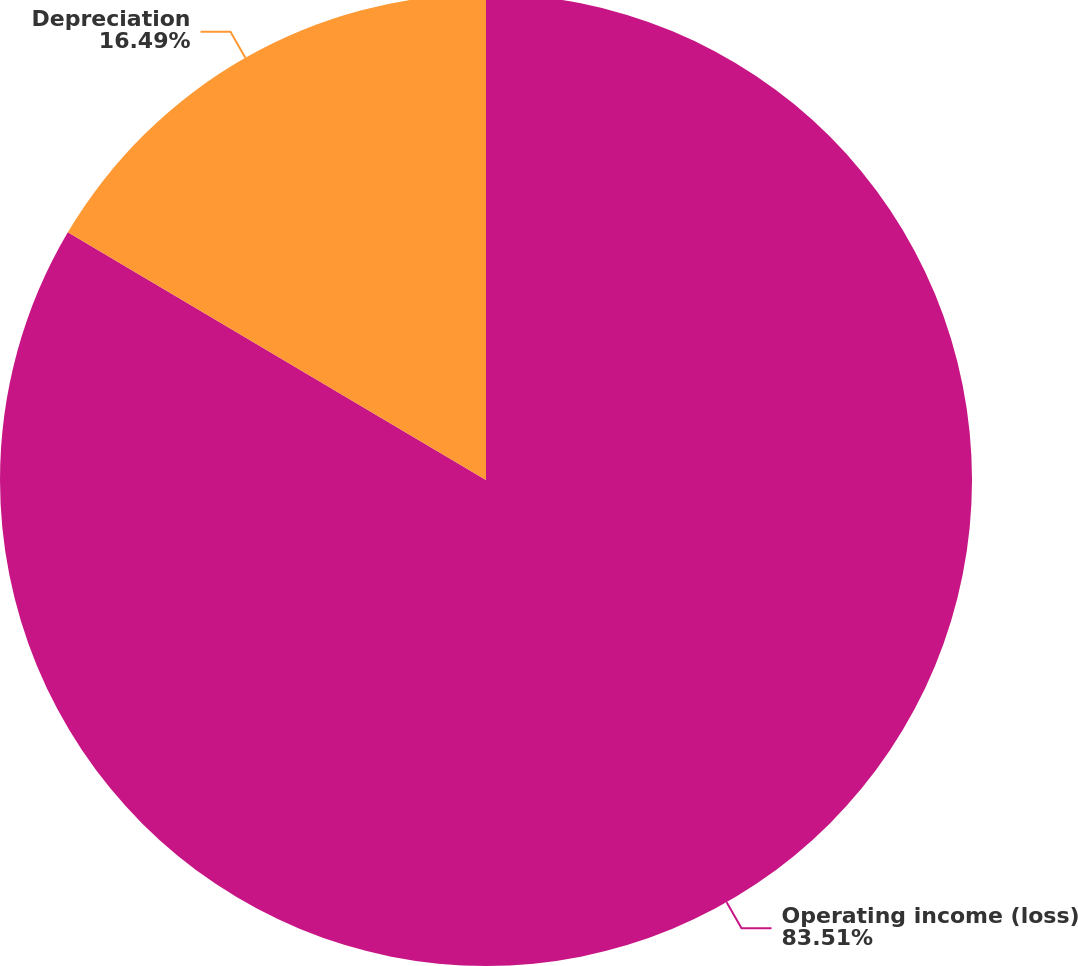<chart> <loc_0><loc_0><loc_500><loc_500><pie_chart><fcel>Operating income (loss)<fcel>Depreciation<nl><fcel>83.51%<fcel>16.49%<nl></chart> 